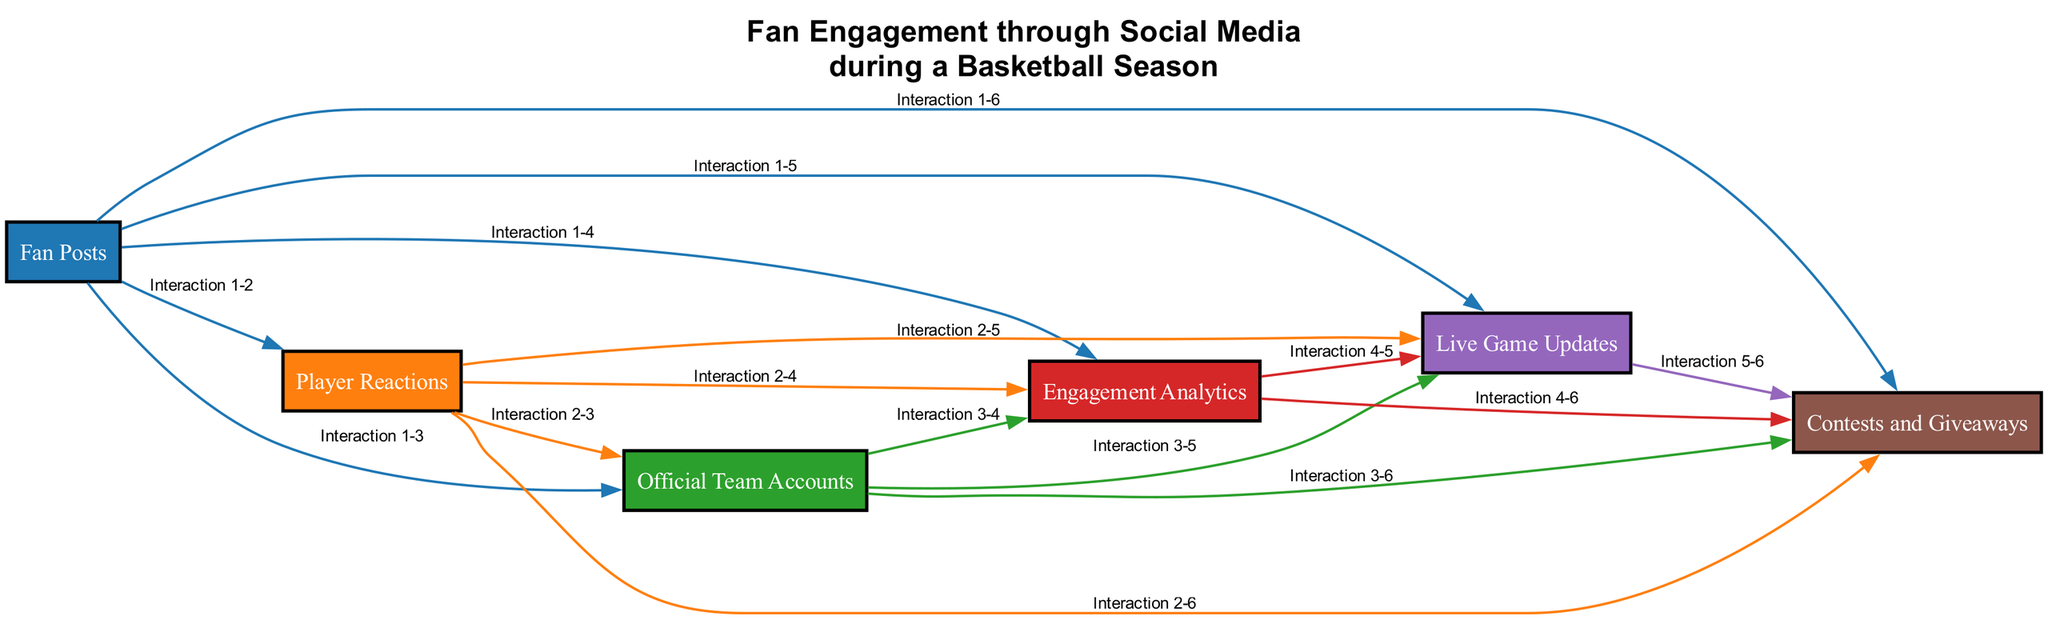What are the elements represented in the diagram? The diagram includes six distinct elements: Fan Posts, Player Reactions, Official Team Accounts, Engagement Analytics, Live Game Updates, and Contests and Giveaways.
Answer: Six Which element is likely to create a sense of connection with fans? Player Reactions, where players respond to fan posts, likely creates a sense of connection.
Answer: Player Reactions How many edges are connecting the nodes? The number of edges can be calculated by finding the combinations of nodes since each node is connected to every other node. With six nodes, the total edges = 6 choose 2 = 15.
Answer: Fifteen What interaction is shown from Fan Posts to Player Reactions? The interaction indicates a reaction from players to the thoughts and posts shared by fans, which may boost engagement.
Answer: Interaction 1-2 Which two elements directly facilitate real-time fan updates during games? Live Game Updates and Official Team Accounts work together to provide real-time updates and commentary during games.
Answer: Live Game Updates and Official Team Accounts What type of promotional activity is included in the diagram? Contests and Giveaways are the promotional activities that encourage fan engagement by offering exciting opportunities like predicting game outcomes.
Answer: Contests and Giveaways How many distinct types of fan engagement are represented? The diagram showcases six distinct types of fan engagement through the various elements outlined.
Answer: Six Which element could be responsible for analyzing engagement metrics? Engagement Analytics is responsible for monitoring and analyzing fan engagement metrics, such as likes, shares, and comments.
Answer: Engagement Analytics 